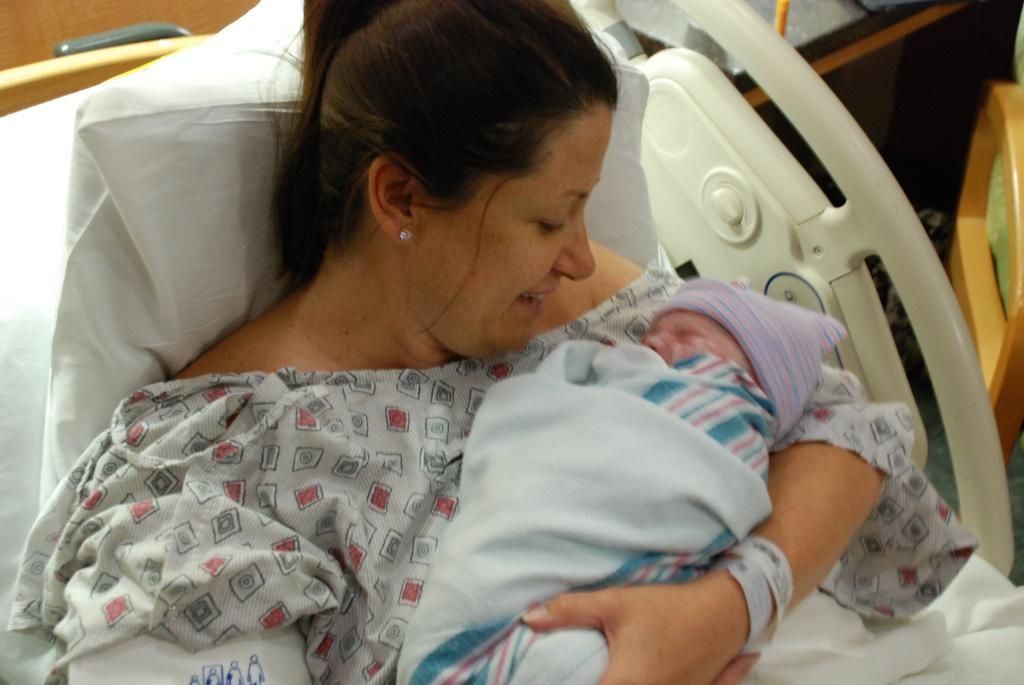Please provide a concise description of this image. In this image there is one woman holding a baby as we can see in middle of this image and there is a pillow at left side of this image and this is in white color. There are some objects kept at right side of this image. 